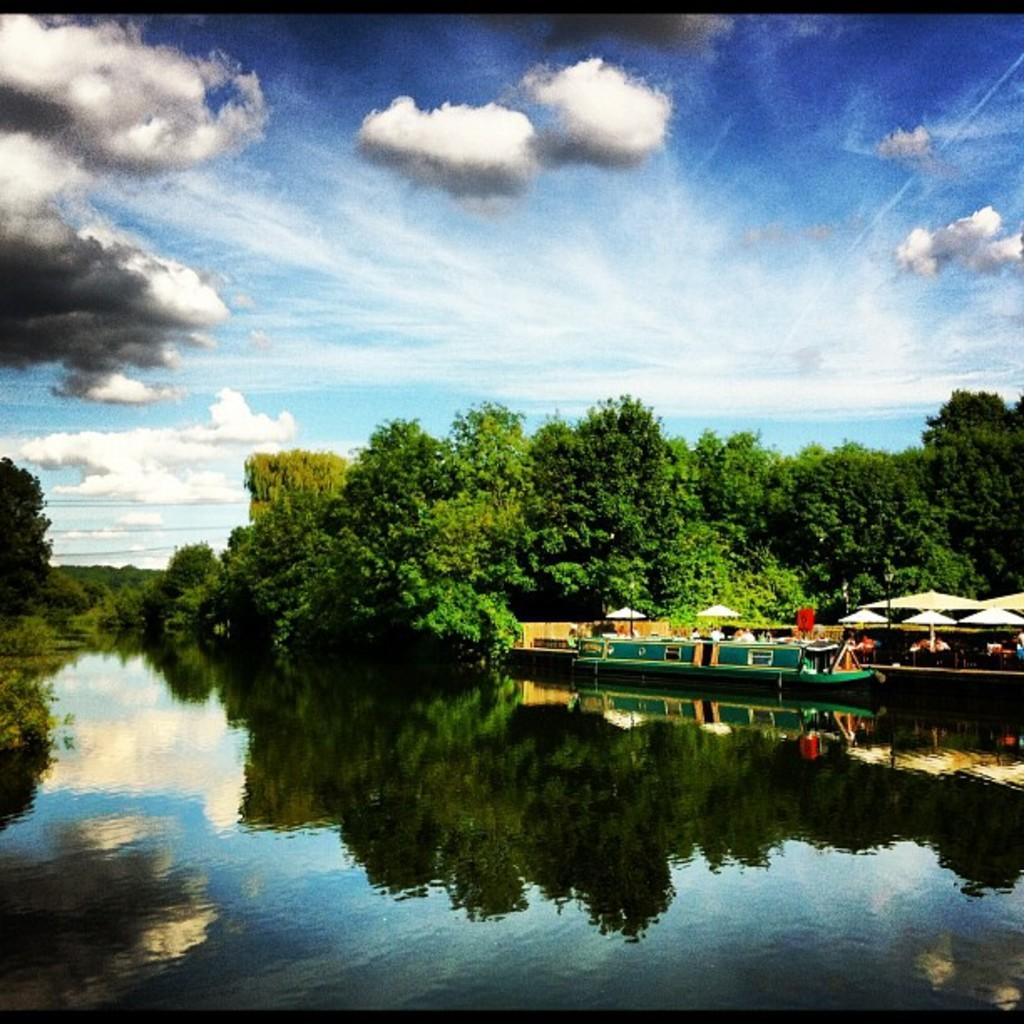What is the main subject of the image? There is a boat on the water in the image. Can you describe the people in the image? There is a group of people in the image. What objects are present in the image that provide shade? There are umbrellas with poles in the image. What type of natural environment is visible in the image? There are trees in the image. What is visible in the background of the image? The sky is visible in the background of the image. What type of street can be seen in the image? There is no street present in the image; it features a boat on the water, a group of people, umbrellas with poles, trees, and the sky in the background. 